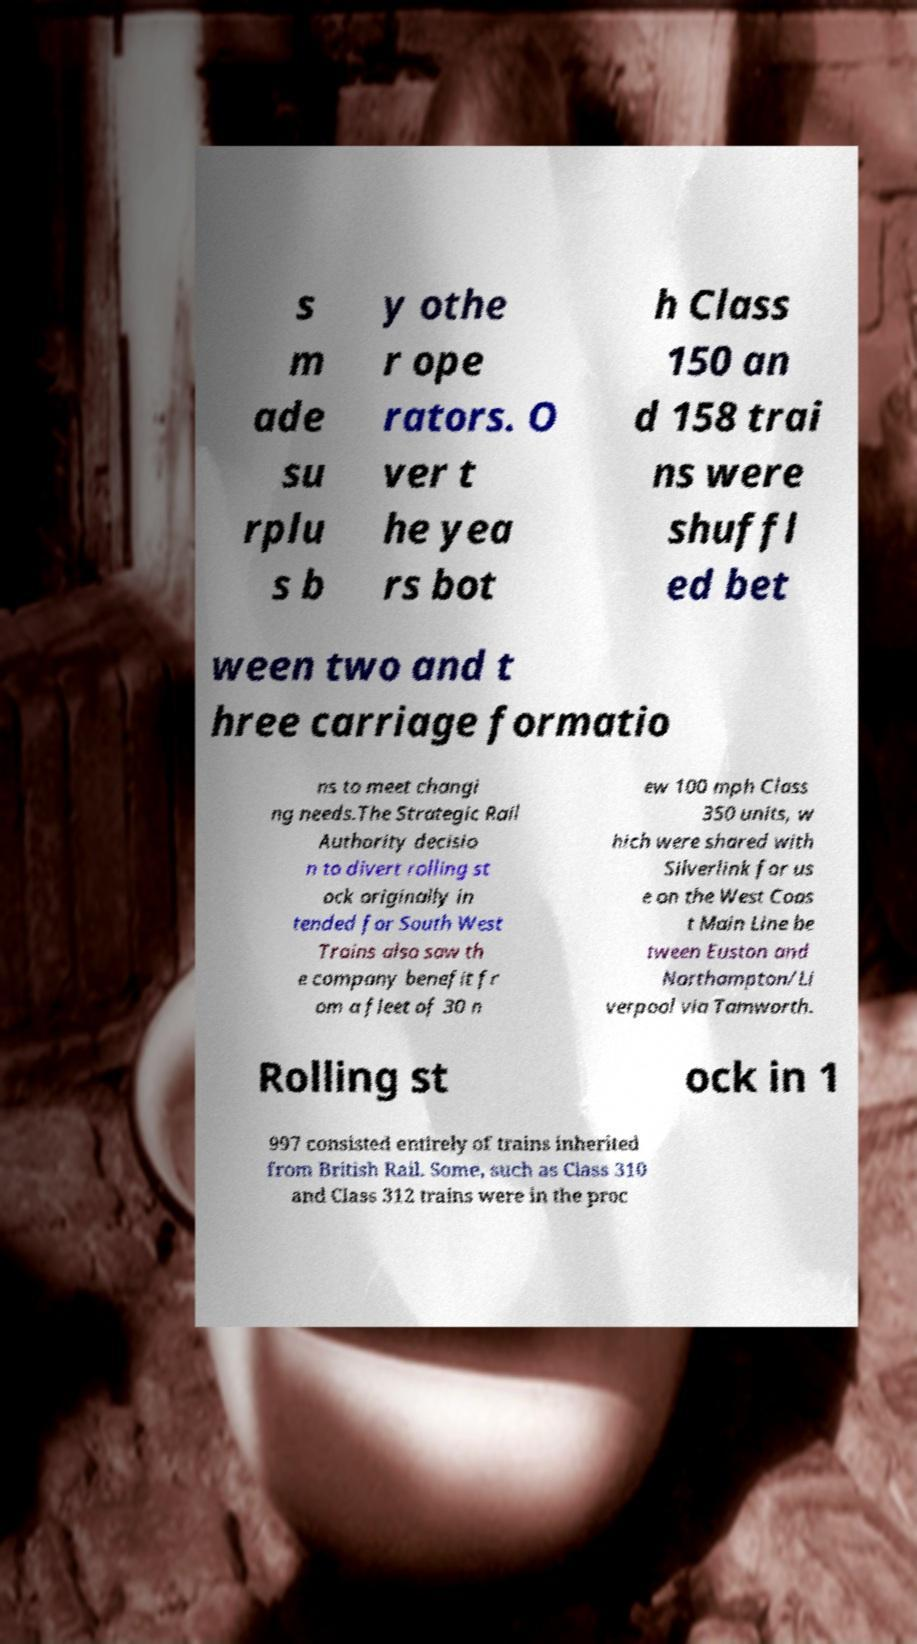Please identify and transcribe the text found in this image. s m ade su rplu s b y othe r ope rators. O ver t he yea rs bot h Class 150 an d 158 trai ns were shuffl ed bet ween two and t hree carriage formatio ns to meet changi ng needs.The Strategic Rail Authority decisio n to divert rolling st ock originally in tended for South West Trains also saw th e company benefit fr om a fleet of 30 n ew 100 mph Class 350 units, w hich were shared with Silverlink for us e on the West Coas t Main Line be tween Euston and Northampton/Li verpool via Tamworth. Rolling st ock in 1 997 consisted entirely of trains inherited from British Rail. Some, such as Class 310 and Class 312 trains were in the proc 